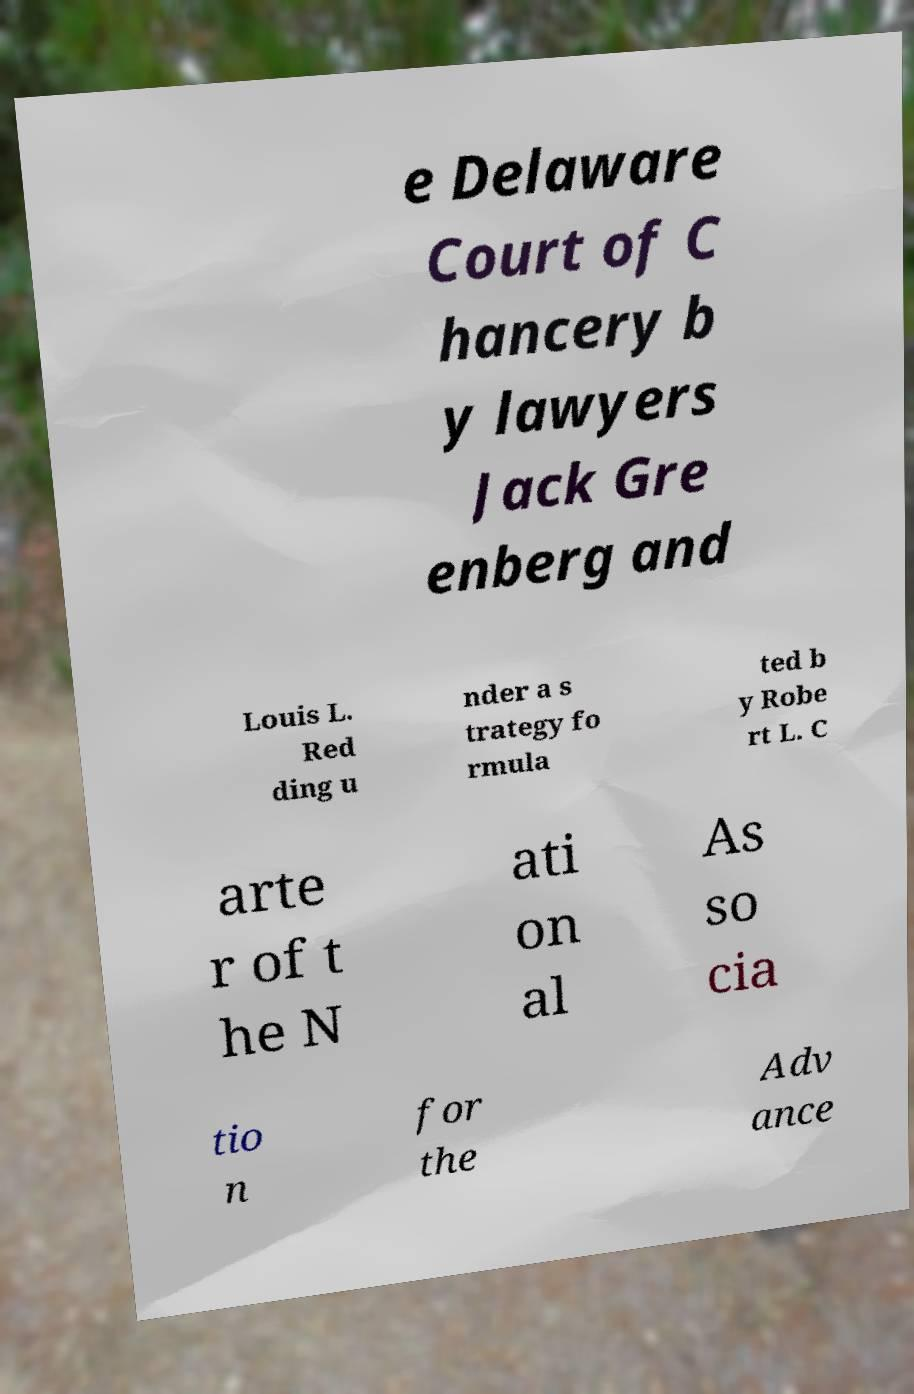Could you extract and type out the text from this image? e Delaware Court of C hancery b y lawyers Jack Gre enberg and Louis L. Red ding u nder a s trategy fo rmula ted b y Robe rt L. C arte r of t he N ati on al As so cia tio n for the Adv ance 